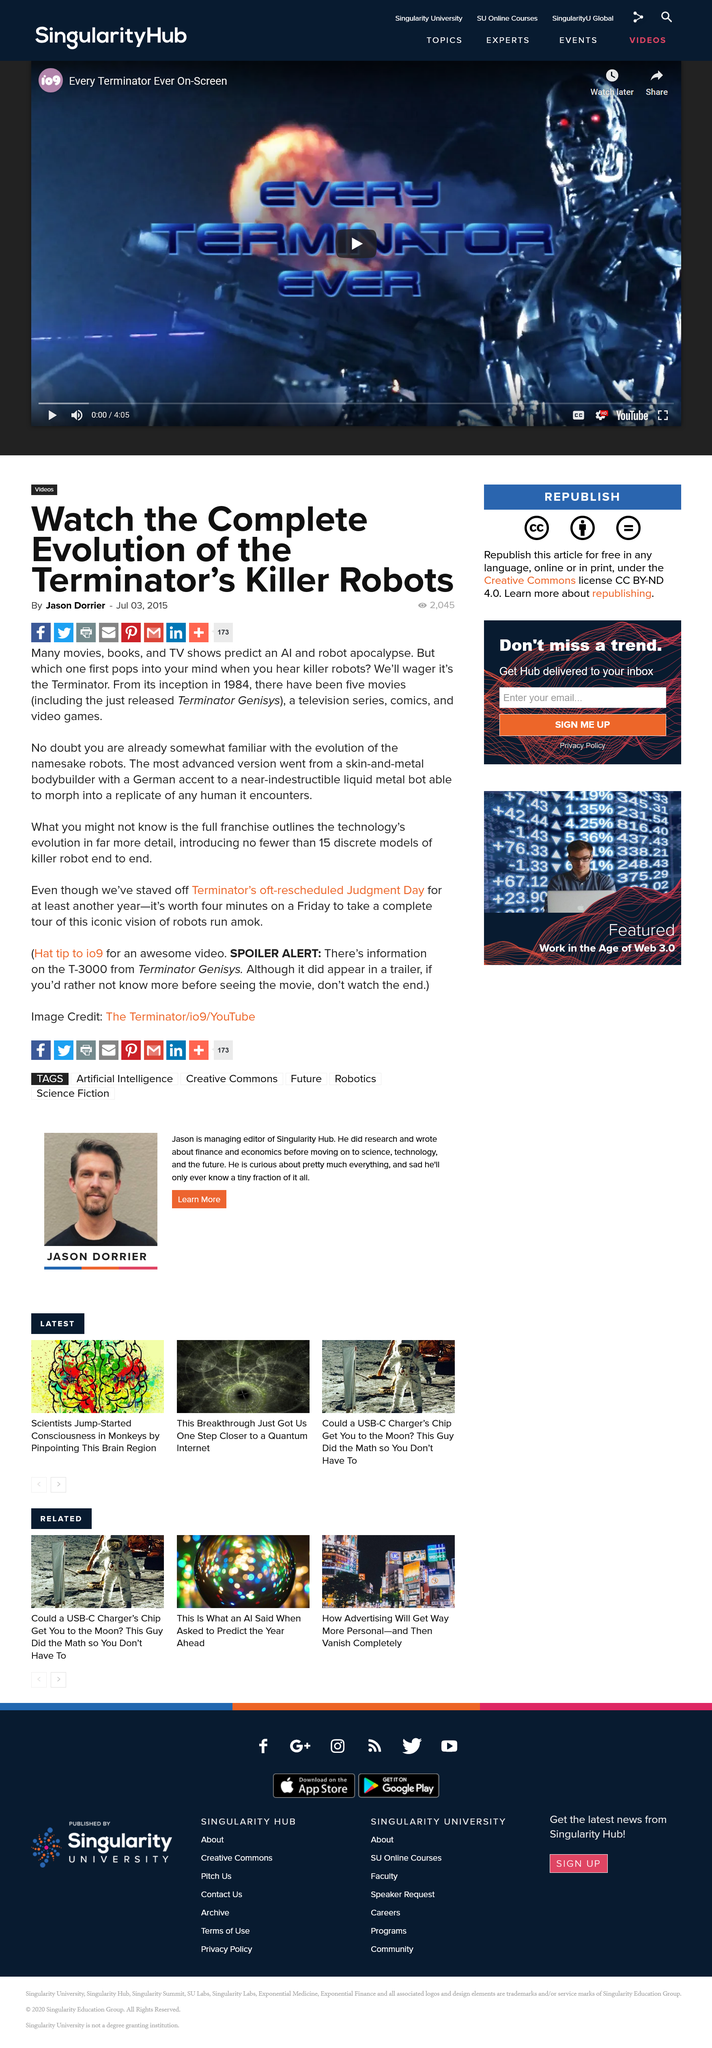Give some essential details in this illustration. The article was published on 3rd July 2015. This article has received 2045 views. The article "Watch the Complete Evolution of the Terminator's Killer Robots" was written by Jason Dorrier. 